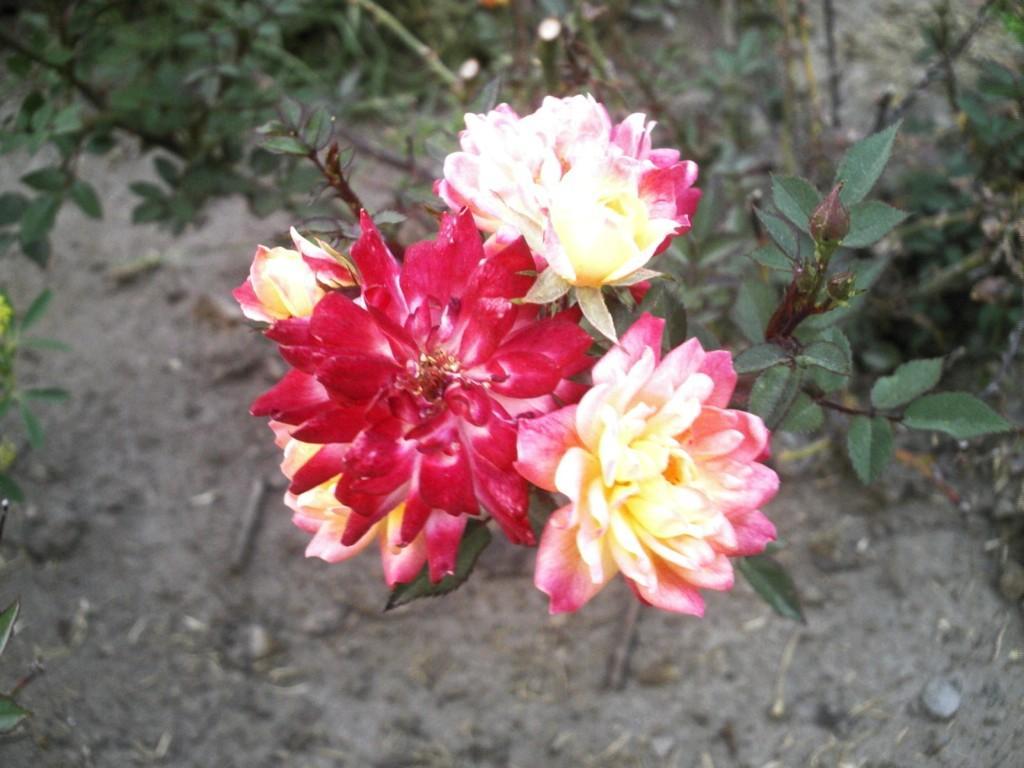How would you summarize this image in a sentence or two? As we can see in the image there are flowers and plants. 